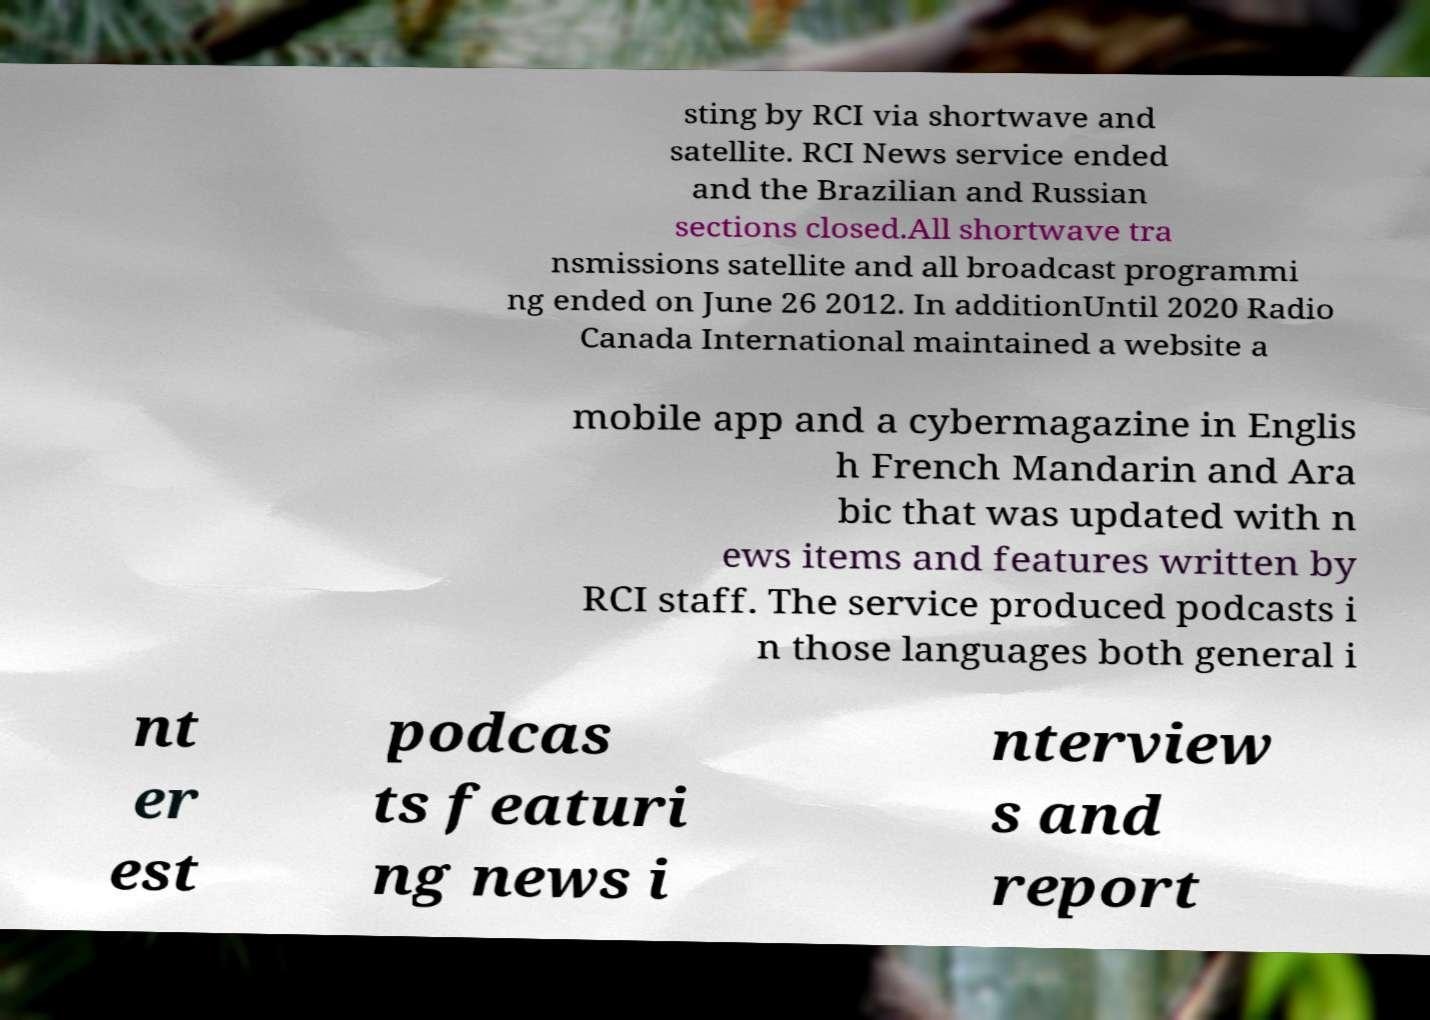Please read and relay the text visible in this image. What does it say? sting by RCI via shortwave and satellite. RCI News service ended and the Brazilian and Russian sections closed.All shortwave tra nsmissions satellite and all broadcast programmi ng ended on June 26 2012. In additionUntil 2020 Radio Canada International maintained a website a mobile app and a cybermagazine in Englis h French Mandarin and Ara bic that was updated with n ews items and features written by RCI staff. The service produced podcasts i n those languages both general i nt er est podcas ts featuri ng news i nterview s and report 